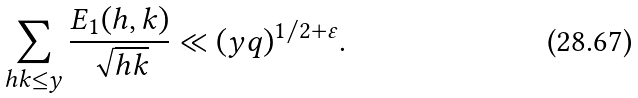<formula> <loc_0><loc_0><loc_500><loc_500>\sum _ { h k \leq y } \frac { E _ { 1 } ( h , k ) } { \sqrt { h k } } \ll ( y q ) ^ { 1 / 2 + \varepsilon } .</formula> 